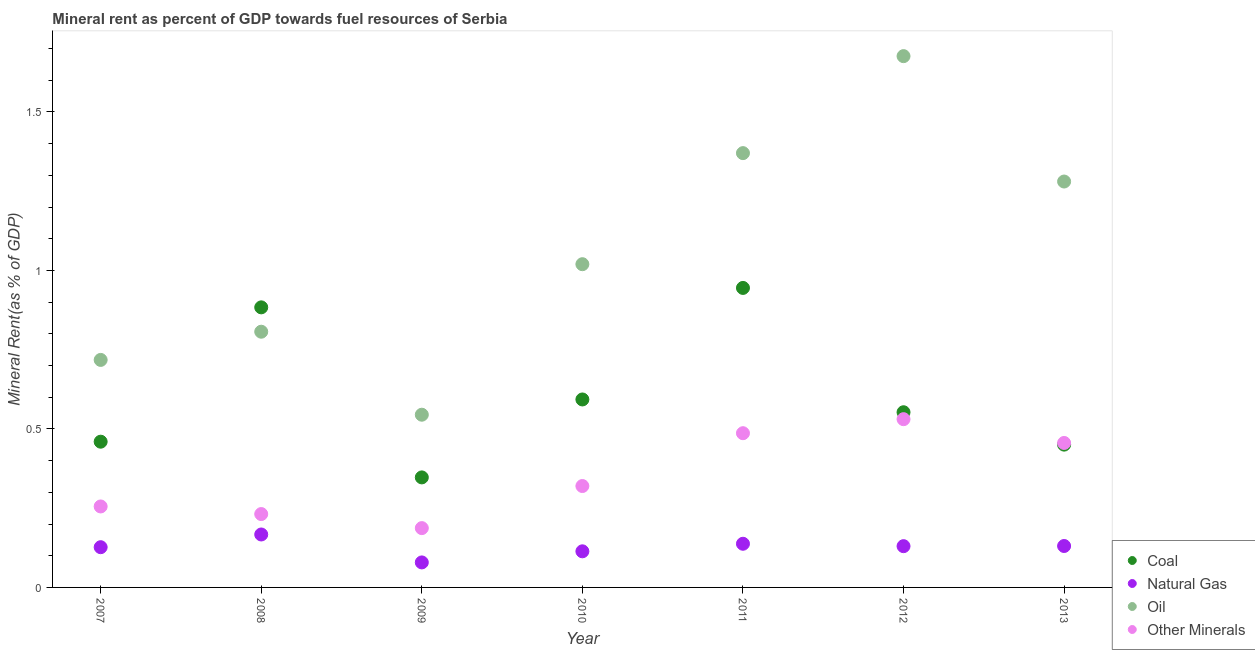What is the oil rent in 2007?
Keep it short and to the point. 0.72. Across all years, what is the maximum oil rent?
Offer a very short reply. 1.68. Across all years, what is the minimum natural gas rent?
Your answer should be very brief. 0.08. In which year was the oil rent minimum?
Your answer should be very brief. 2009. What is the total  rent of other minerals in the graph?
Your response must be concise. 2.47. What is the difference between the natural gas rent in 2007 and that in 2009?
Ensure brevity in your answer.  0.05. What is the difference between the coal rent in 2011 and the oil rent in 2012?
Provide a succinct answer. -0.73. What is the average oil rent per year?
Ensure brevity in your answer.  1.06. In the year 2012, what is the difference between the coal rent and oil rent?
Give a very brief answer. -1.12. In how many years, is the oil rent greater than 1.6 %?
Your answer should be very brief. 1. What is the ratio of the  rent of other minerals in 2009 to that in 2013?
Offer a very short reply. 0.41. What is the difference between the highest and the second highest natural gas rent?
Ensure brevity in your answer.  0.03. What is the difference between the highest and the lowest natural gas rent?
Your answer should be very brief. 0.09. In how many years, is the coal rent greater than the average coal rent taken over all years?
Keep it short and to the point. 2. Is the sum of the coal rent in 2010 and 2013 greater than the maximum  rent of other minerals across all years?
Keep it short and to the point. Yes. Is it the case that in every year, the sum of the coal rent and natural gas rent is greater than the sum of  rent of other minerals and oil rent?
Your answer should be compact. No. Is it the case that in every year, the sum of the coal rent and natural gas rent is greater than the oil rent?
Offer a very short reply. No. Does the  rent of other minerals monotonically increase over the years?
Provide a short and direct response. No. How many years are there in the graph?
Provide a short and direct response. 7. Are the values on the major ticks of Y-axis written in scientific E-notation?
Provide a short and direct response. No. Does the graph contain any zero values?
Your response must be concise. No. Does the graph contain grids?
Your answer should be compact. No. Where does the legend appear in the graph?
Provide a short and direct response. Bottom right. How many legend labels are there?
Your response must be concise. 4. What is the title of the graph?
Provide a succinct answer. Mineral rent as percent of GDP towards fuel resources of Serbia. What is the label or title of the X-axis?
Your answer should be very brief. Year. What is the label or title of the Y-axis?
Provide a short and direct response. Mineral Rent(as % of GDP). What is the Mineral Rent(as % of GDP) of Coal in 2007?
Ensure brevity in your answer.  0.46. What is the Mineral Rent(as % of GDP) of Natural Gas in 2007?
Your response must be concise. 0.13. What is the Mineral Rent(as % of GDP) in Oil in 2007?
Provide a succinct answer. 0.72. What is the Mineral Rent(as % of GDP) in Other Minerals in 2007?
Offer a terse response. 0.26. What is the Mineral Rent(as % of GDP) of Coal in 2008?
Your answer should be very brief. 0.88. What is the Mineral Rent(as % of GDP) in Natural Gas in 2008?
Ensure brevity in your answer.  0.17. What is the Mineral Rent(as % of GDP) of Oil in 2008?
Your answer should be very brief. 0.81. What is the Mineral Rent(as % of GDP) of Other Minerals in 2008?
Your answer should be compact. 0.23. What is the Mineral Rent(as % of GDP) in Coal in 2009?
Your answer should be compact. 0.35. What is the Mineral Rent(as % of GDP) of Natural Gas in 2009?
Provide a short and direct response. 0.08. What is the Mineral Rent(as % of GDP) in Oil in 2009?
Offer a terse response. 0.54. What is the Mineral Rent(as % of GDP) of Other Minerals in 2009?
Your response must be concise. 0.19. What is the Mineral Rent(as % of GDP) of Coal in 2010?
Give a very brief answer. 0.59. What is the Mineral Rent(as % of GDP) of Natural Gas in 2010?
Provide a succinct answer. 0.11. What is the Mineral Rent(as % of GDP) of Oil in 2010?
Make the answer very short. 1.02. What is the Mineral Rent(as % of GDP) of Other Minerals in 2010?
Make the answer very short. 0.32. What is the Mineral Rent(as % of GDP) in Coal in 2011?
Offer a very short reply. 0.94. What is the Mineral Rent(as % of GDP) in Natural Gas in 2011?
Your answer should be very brief. 0.14. What is the Mineral Rent(as % of GDP) of Oil in 2011?
Your answer should be compact. 1.37. What is the Mineral Rent(as % of GDP) of Other Minerals in 2011?
Offer a very short reply. 0.49. What is the Mineral Rent(as % of GDP) of Coal in 2012?
Keep it short and to the point. 0.55. What is the Mineral Rent(as % of GDP) of Natural Gas in 2012?
Offer a terse response. 0.13. What is the Mineral Rent(as % of GDP) of Oil in 2012?
Offer a very short reply. 1.68. What is the Mineral Rent(as % of GDP) in Other Minerals in 2012?
Your answer should be compact. 0.53. What is the Mineral Rent(as % of GDP) of Coal in 2013?
Offer a very short reply. 0.45. What is the Mineral Rent(as % of GDP) in Natural Gas in 2013?
Ensure brevity in your answer.  0.13. What is the Mineral Rent(as % of GDP) in Oil in 2013?
Ensure brevity in your answer.  1.28. What is the Mineral Rent(as % of GDP) in Other Minerals in 2013?
Offer a terse response. 0.46. Across all years, what is the maximum Mineral Rent(as % of GDP) in Coal?
Your answer should be very brief. 0.94. Across all years, what is the maximum Mineral Rent(as % of GDP) in Natural Gas?
Make the answer very short. 0.17. Across all years, what is the maximum Mineral Rent(as % of GDP) of Oil?
Your response must be concise. 1.68. Across all years, what is the maximum Mineral Rent(as % of GDP) of Other Minerals?
Ensure brevity in your answer.  0.53. Across all years, what is the minimum Mineral Rent(as % of GDP) of Coal?
Ensure brevity in your answer.  0.35. Across all years, what is the minimum Mineral Rent(as % of GDP) in Natural Gas?
Give a very brief answer. 0.08. Across all years, what is the minimum Mineral Rent(as % of GDP) in Oil?
Your answer should be very brief. 0.54. Across all years, what is the minimum Mineral Rent(as % of GDP) of Other Minerals?
Provide a succinct answer. 0.19. What is the total Mineral Rent(as % of GDP) in Coal in the graph?
Ensure brevity in your answer.  4.23. What is the total Mineral Rent(as % of GDP) of Natural Gas in the graph?
Offer a very short reply. 0.89. What is the total Mineral Rent(as % of GDP) of Oil in the graph?
Offer a very short reply. 7.42. What is the total Mineral Rent(as % of GDP) of Other Minerals in the graph?
Provide a short and direct response. 2.47. What is the difference between the Mineral Rent(as % of GDP) of Coal in 2007 and that in 2008?
Your answer should be very brief. -0.42. What is the difference between the Mineral Rent(as % of GDP) in Natural Gas in 2007 and that in 2008?
Your answer should be compact. -0.04. What is the difference between the Mineral Rent(as % of GDP) of Oil in 2007 and that in 2008?
Give a very brief answer. -0.09. What is the difference between the Mineral Rent(as % of GDP) in Other Minerals in 2007 and that in 2008?
Give a very brief answer. 0.02. What is the difference between the Mineral Rent(as % of GDP) of Coal in 2007 and that in 2009?
Give a very brief answer. 0.11. What is the difference between the Mineral Rent(as % of GDP) of Natural Gas in 2007 and that in 2009?
Offer a terse response. 0.05. What is the difference between the Mineral Rent(as % of GDP) in Oil in 2007 and that in 2009?
Your response must be concise. 0.17. What is the difference between the Mineral Rent(as % of GDP) of Other Minerals in 2007 and that in 2009?
Offer a terse response. 0.07. What is the difference between the Mineral Rent(as % of GDP) in Coal in 2007 and that in 2010?
Provide a short and direct response. -0.13. What is the difference between the Mineral Rent(as % of GDP) in Natural Gas in 2007 and that in 2010?
Provide a short and direct response. 0.01. What is the difference between the Mineral Rent(as % of GDP) of Oil in 2007 and that in 2010?
Your answer should be very brief. -0.3. What is the difference between the Mineral Rent(as % of GDP) of Other Minerals in 2007 and that in 2010?
Keep it short and to the point. -0.06. What is the difference between the Mineral Rent(as % of GDP) in Coal in 2007 and that in 2011?
Provide a succinct answer. -0.49. What is the difference between the Mineral Rent(as % of GDP) in Natural Gas in 2007 and that in 2011?
Provide a succinct answer. -0.01. What is the difference between the Mineral Rent(as % of GDP) of Oil in 2007 and that in 2011?
Make the answer very short. -0.65. What is the difference between the Mineral Rent(as % of GDP) of Other Minerals in 2007 and that in 2011?
Provide a short and direct response. -0.23. What is the difference between the Mineral Rent(as % of GDP) in Coal in 2007 and that in 2012?
Keep it short and to the point. -0.09. What is the difference between the Mineral Rent(as % of GDP) of Natural Gas in 2007 and that in 2012?
Provide a succinct answer. -0. What is the difference between the Mineral Rent(as % of GDP) of Oil in 2007 and that in 2012?
Offer a very short reply. -0.96. What is the difference between the Mineral Rent(as % of GDP) of Other Minerals in 2007 and that in 2012?
Give a very brief answer. -0.28. What is the difference between the Mineral Rent(as % of GDP) of Coal in 2007 and that in 2013?
Give a very brief answer. 0.01. What is the difference between the Mineral Rent(as % of GDP) in Natural Gas in 2007 and that in 2013?
Your answer should be very brief. -0. What is the difference between the Mineral Rent(as % of GDP) of Oil in 2007 and that in 2013?
Your response must be concise. -0.56. What is the difference between the Mineral Rent(as % of GDP) in Other Minerals in 2007 and that in 2013?
Your answer should be compact. -0.2. What is the difference between the Mineral Rent(as % of GDP) in Coal in 2008 and that in 2009?
Provide a succinct answer. 0.54. What is the difference between the Mineral Rent(as % of GDP) of Natural Gas in 2008 and that in 2009?
Make the answer very short. 0.09. What is the difference between the Mineral Rent(as % of GDP) in Oil in 2008 and that in 2009?
Give a very brief answer. 0.26. What is the difference between the Mineral Rent(as % of GDP) of Other Minerals in 2008 and that in 2009?
Provide a short and direct response. 0.04. What is the difference between the Mineral Rent(as % of GDP) of Coal in 2008 and that in 2010?
Offer a terse response. 0.29. What is the difference between the Mineral Rent(as % of GDP) of Natural Gas in 2008 and that in 2010?
Ensure brevity in your answer.  0.05. What is the difference between the Mineral Rent(as % of GDP) of Oil in 2008 and that in 2010?
Give a very brief answer. -0.21. What is the difference between the Mineral Rent(as % of GDP) in Other Minerals in 2008 and that in 2010?
Keep it short and to the point. -0.09. What is the difference between the Mineral Rent(as % of GDP) in Coal in 2008 and that in 2011?
Make the answer very short. -0.06. What is the difference between the Mineral Rent(as % of GDP) in Natural Gas in 2008 and that in 2011?
Offer a terse response. 0.03. What is the difference between the Mineral Rent(as % of GDP) of Oil in 2008 and that in 2011?
Offer a very short reply. -0.56. What is the difference between the Mineral Rent(as % of GDP) of Other Minerals in 2008 and that in 2011?
Your answer should be compact. -0.26. What is the difference between the Mineral Rent(as % of GDP) of Coal in 2008 and that in 2012?
Your answer should be very brief. 0.33. What is the difference between the Mineral Rent(as % of GDP) in Natural Gas in 2008 and that in 2012?
Your response must be concise. 0.04. What is the difference between the Mineral Rent(as % of GDP) of Oil in 2008 and that in 2012?
Your answer should be very brief. -0.87. What is the difference between the Mineral Rent(as % of GDP) in Other Minerals in 2008 and that in 2012?
Offer a very short reply. -0.3. What is the difference between the Mineral Rent(as % of GDP) of Coal in 2008 and that in 2013?
Your response must be concise. 0.43. What is the difference between the Mineral Rent(as % of GDP) in Natural Gas in 2008 and that in 2013?
Your answer should be compact. 0.04. What is the difference between the Mineral Rent(as % of GDP) in Oil in 2008 and that in 2013?
Provide a succinct answer. -0.47. What is the difference between the Mineral Rent(as % of GDP) of Other Minerals in 2008 and that in 2013?
Make the answer very short. -0.22. What is the difference between the Mineral Rent(as % of GDP) in Coal in 2009 and that in 2010?
Your answer should be compact. -0.25. What is the difference between the Mineral Rent(as % of GDP) of Natural Gas in 2009 and that in 2010?
Keep it short and to the point. -0.04. What is the difference between the Mineral Rent(as % of GDP) in Oil in 2009 and that in 2010?
Give a very brief answer. -0.47. What is the difference between the Mineral Rent(as % of GDP) in Other Minerals in 2009 and that in 2010?
Offer a very short reply. -0.13. What is the difference between the Mineral Rent(as % of GDP) in Coal in 2009 and that in 2011?
Offer a very short reply. -0.6. What is the difference between the Mineral Rent(as % of GDP) of Natural Gas in 2009 and that in 2011?
Give a very brief answer. -0.06. What is the difference between the Mineral Rent(as % of GDP) in Oil in 2009 and that in 2011?
Give a very brief answer. -0.83. What is the difference between the Mineral Rent(as % of GDP) of Other Minerals in 2009 and that in 2011?
Your response must be concise. -0.3. What is the difference between the Mineral Rent(as % of GDP) in Coal in 2009 and that in 2012?
Provide a short and direct response. -0.21. What is the difference between the Mineral Rent(as % of GDP) in Natural Gas in 2009 and that in 2012?
Make the answer very short. -0.05. What is the difference between the Mineral Rent(as % of GDP) of Oil in 2009 and that in 2012?
Offer a terse response. -1.13. What is the difference between the Mineral Rent(as % of GDP) of Other Minerals in 2009 and that in 2012?
Your answer should be compact. -0.34. What is the difference between the Mineral Rent(as % of GDP) of Coal in 2009 and that in 2013?
Provide a succinct answer. -0.1. What is the difference between the Mineral Rent(as % of GDP) in Natural Gas in 2009 and that in 2013?
Provide a short and direct response. -0.05. What is the difference between the Mineral Rent(as % of GDP) in Oil in 2009 and that in 2013?
Keep it short and to the point. -0.74. What is the difference between the Mineral Rent(as % of GDP) of Other Minerals in 2009 and that in 2013?
Make the answer very short. -0.27. What is the difference between the Mineral Rent(as % of GDP) in Coal in 2010 and that in 2011?
Give a very brief answer. -0.35. What is the difference between the Mineral Rent(as % of GDP) of Natural Gas in 2010 and that in 2011?
Ensure brevity in your answer.  -0.02. What is the difference between the Mineral Rent(as % of GDP) in Oil in 2010 and that in 2011?
Give a very brief answer. -0.35. What is the difference between the Mineral Rent(as % of GDP) in Coal in 2010 and that in 2012?
Offer a very short reply. 0.04. What is the difference between the Mineral Rent(as % of GDP) in Natural Gas in 2010 and that in 2012?
Keep it short and to the point. -0.02. What is the difference between the Mineral Rent(as % of GDP) in Oil in 2010 and that in 2012?
Keep it short and to the point. -0.66. What is the difference between the Mineral Rent(as % of GDP) in Other Minerals in 2010 and that in 2012?
Ensure brevity in your answer.  -0.21. What is the difference between the Mineral Rent(as % of GDP) of Coal in 2010 and that in 2013?
Provide a succinct answer. 0.14. What is the difference between the Mineral Rent(as % of GDP) of Natural Gas in 2010 and that in 2013?
Provide a succinct answer. -0.02. What is the difference between the Mineral Rent(as % of GDP) of Oil in 2010 and that in 2013?
Your answer should be compact. -0.26. What is the difference between the Mineral Rent(as % of GDP) of Other Minerals in 2010 and that in 2013?
Keep it short and to the point. -0.14. What is the difference between the Mineral Rent(as % of GDP) of Coal in 2011 and that in 2012?
Make the answer very short. 0.39. What is the difference between the Mineral Rent(as % of GDP) in Natural Gas in 2011 and that in 2012?
Offer a very short reply. 0.01. What is the difference between the Mineral Rent(as % of GDP) of Oil in 2011 and that in 2012?
Offer a terse response. -0.31. What is the difference between the Mineral Rent(as % of GDP) in Other Minerals in 2011 and that in 2012?
Make the answer very short. -0.04. What is the difference between the Mineral Rent(as % of GDP) in Coal in 2011 and that in 2013?
Give a very brief answer. 0.49. What is the difference between the Mineral Rent(as % of GDP) of Natural Gas in 2011 and that in 2013?
Make the answer very short. 0.01. What is the difference between the Mineral Rent(as % of GDP) of Oil in 2011 and that in 2013?
Provide a short and direct response. 0.09. What is the difference between the Mineral Rent(as % of GDP) in Other Minerals in 2011 and that in 2013?
Offer a terse response. 0.03. What is the difference between the Mineral Rent(as % of GDP) in Coal in 2012 and that in 2013?
Your answer should be very brief. 0.1. What is the difference between the Mineral Rent(as % of GDP) of Natural Gas in 2012 and that in 2013?
Offer a terse response. -0. What is the difference between the Mineral Rent(as % of GDP) in Oil in 2012 and that in 2013?
Your answer should be compact. 0.4. What is the difference between the Mineral Rent(as % of GDP) of Other Minerals in 2012 and that in 2013?
Offer a very short reply. 0.07. What is the difference between the Mineral Rent(as % of GDP) in Coal in 2007 and the Mineral Rent(as % of GDP) in Natural Gas in 2008?
Your answer should be very brief. 0.29. What is the difference between the Mineral Rent(as % of GDP) in Coal in 2007 and the Mineral Rent(as % of GDP) in Oil in 2008?
Provide a short and direct response. -0.35. What is the difference between the Mineral Rent(as % of GDP) in Coal in 2007 and the Mineral Rent(as % of GDP) in Other Minerals in 2008?
Your response must be concise. 0.23. What is the difference between the Mineral Rent(as % of GDP) of Natural Gas in 2007 and the Mineral Rent(as % of GDP) of Oil in 2008?
Give a very brief answer. -0.68. What is the difference between the Mineral Rent(as % of GDP) of Natural Gas in 2007 and the Mineral Rent(as % of GDP) of Other Minerals in 2008?
Your answer should be compact. -0.1. What is the difference between the Mineral Rent(as % of GDP) of Oil in 2007 and the Mineral Rent(as % of GDP) of Other Minerals in 2008?
Offer a terse response. 0.49. What is the difference between the Mineral Rent(as % of GDP) in Coal in 2007 and the Mineral Rent(as % of GDP) in Natural Gas in 2009?
Offer a terse response. 0.38. What is the difference between the Mineral Rent(as % of GDP) of Coal in 2007 and the Mineral Rent(as % of GDP) of Oil in 2009?
Offer a terse response. -0.09. What is the difference between the Mineral Rent(as % of GDP) of Coal in 2007 and the Mineral Rent(as % of GDP) of Other Minerals in 2009?
Your response must be concise. 0.27. What is the difference between the Mineral Rent(as % of GDP) of Natural Gas in 2007 and the Mineral Rent(as % of GDP) of Oil in 2009?
Give a very brief answer. -0.42. What is the difference between the Mineral Rent(as % of GDP) in Natural Gas in 2007 and the Mineral Rent(as % of GDP) in Other Minerals in 2009?
Ensure brevity in your answer.  -0.06. What is the difference between the Mineral Rent(as % of GDP) of Oil in 2007 and the Mineral Rent(as % of GDP) of Other Minerals in 2009?
Your answer should be very brief. 0.53. What is the difference between the Mineral Rent(as % of GDP) in Coal in 2007 and the Mineral Rent(as % of GDP) in Natural Gas in 2010?
Offer a very short reply. 0.35. What is the difference between the Mineral Rent(as % of GDP) of Coal in 2007 and the Mineral Rent(as % of GDP) of Oil in 2010?
Provide a succinct answer. -0.56. What is the difference between the Mineral Rent(as % of GDP) in Coal in 2007 and the Mineral Rent(as % of GDP) in Other Minerals in 2010?
Offer a terse response. 0.14. What is the difference between the Mineral Rent(as % of GDP) in Natural Gas in 2007 and the Mineral Rent(as % of GDP) in Oil in 2010?
Offer a terse response. -0.89. What is the difference between the Mineral Rent(as % of GDP) in Natural Gas in 2007 and the Mineral Rent(as % of GDP) in Other Minerals in 2010?
Offer a very short reply. -0.19. What is the difference between the Mineral Rent(as % of GDP) in Oil in 2007 and the Mineral Rent(as % of GDP) in Other Minerals in 2010?
Give a very brief answer. 0.4. What is the difference between the Mineral Rent(as % of GDP) of Coal in 2007 and the Mineral Rent(as % of GDP) of Natural Gas in 2011?
Give a very brief answer. 0.32. What is the difference between the Mineral Rent(as % of GDP) in Coal in 2007 and the Mineral Rent(as % of GDP) in Oil in 2011?
Give a very brief answer. -0.91. What is the difference between the Mineral Rent(as % of GDP) in Coal in 2007 and the Mineral Rent(as % of GDP) in Other Minerals in 2011?
Keep it short and to the point. -0.03. What is the difference between the Mineral Rent(as % of GDP) of Natural Gas in 2007 and the Mineral Rent(as % of GDP) of Oil in 2011?
Give a very brief answer. -1.24. What is the difference between the Mineral Rent(as % of GDP) of Natural Gas in 2007 and the Mineral Rent(as % of GDP) of Other Minerals in 2011?
Keep it short and to the point. -0.36. What is the difference between the Mineral Rent(as % of GDP) of Oil in 2007 and the Mineral Rent(as % of GDP) of Other Minerals in 2011?
Give a very brief answer. 0.23. What is the difference between the Mineral Rent(as % of GDP) of Coal in 2007 and the Mineral Rent(as % of GDP) of Natural Gas in 2012?
Offer a terse response. 0.33. What is the difference between the Mineral Rent(as % of GDP) of Coal in 2007 and the Mineral Rent(as % of GDP) of Oil in 2012?
Offer a terse response. -1.22. What is the difference between the Mineral Rent(as % of GDP) of Coal in 2007 and the Mineral Rent(as % of GDP) of Other Minerals in 2012?
Make the answer very short. -0.07. What is the difference between the Mineral Rent(as % of GDP) in Natural Gas in 2007 and the Mineral Rent(as % of GDP) in Oil in 2012?
Your answer should be very brief. -1.55. What is the difference between the Mineral Rent(as % of GDP) in Natural Gas in 2007 and the Mineral Rent(as % of GDP) in Other Minerals in 2012?
Your response must be concise. -0.4. What is the difference between the Mineral Rent(as % of GDP) in Oil in 2007 and the Mineral Rent(as % of GDP) in Other Minerals in 2012?
Ensure brevity in your answer.  0.19. What is the difference between the Mineral Rent(as % of GDP) in Coal in 2007 and the Mineral Rent(as % of GDP) in Natural Gas in 2013?
Your response must be concise. 0.33. What is the difference between the Mineral Rent(as % of GDP) in Coal in 2007 and the Mineral Rent(as % of GDP) in Oil in 2013?
Provide a short and direct response. -0.82. What is the difference between the Mineral Rent(as % of GDP) of Coal in 2007 and the Mineral Rent(as % of GDP) of Other Minerals in 2013?
Your answer should be compact. 0. What is the difference between the Mineral Rent(as % of GDP) of Natural Gas in 2007 and the Mineral Rent(as % of GDP) of Oil in 2013?
Your answer should be very brief. -1.15. What is the difference between the Mineral Rent(as % of GDP) of Natural Gas in 2007 and the Mineral Rent(as % of GDP) of Other Minerals in 2013?
Your response must be concise. -0.33. What is the difference between the Mineral Rent(as % of GDP) in Oil in 2007 and the Mineral Rent(as % of GDP) in Other Minerals in 2013?
Ensure brevity in your answer.  0.26. What is the difference between the Mineral Rent(as % of GDP) of Coal in 2008 and the Mineral Rent(as % of GDP) of Natural Gas in 2009?
Provide a succinct answer. 0.8. What is the difference between the Mineral Rent(as % of GDP) of Coal in 2008 and the Mineral Rent(as % of GDP) of Oil in 2009?
Give a very brief answer. 0.34. What is the difference between the Mineral Rent(as % of GDP) of Coal in 2008 and the Mineral Rent(as % of GDP) of Other Minerals in 2009?
Your response must be concise. 0.7. What is the difference between the Mineral Rent(as % of GDP) of Natural Gas in 2008 and the Mineral Rent(as % of GDP) of Oil in 2009?
Give a very brief answer. -0.38. What is the difference between the Mineral Rent(as % of GDP) of Natural Gas in 2008 and the Mineral Rent(as % of GDP) of Other Minerals in 2009?
Make the answer very short. -0.02. What is the difference between the Mineral Rent(as % of GDP) in Oil in 2008 and the Mineral Rent(as % of GDP) in Other Minerals in 2009?
Offer a terse response. 0.62. What is the difference between the Mineral Rent(as % of GDP) of Coal in 2008 and the Mineral Rent(as % of GDP) of Natural Gas in 2010?
Your answer should be very brief. 0.77. What is the difference between the Mineral Rent(as % of GDP) in Coal in 2008 and the Mineral Rent(as % of GDP) in Oil in 2010?
Provide a succinct answer. -0.14. What is the difference between the Mineral Rent(as % of GDP) of Coal in 2008 and the Mineral Rent(as % of GDP) of Other Minerals in 2010?
Ensure brevity in your answer.  0.56. What is the difference between the Mineral Rent(as % of GDP) of Natural Gas in 2008 and the Mineral Rent(as % of GDP) of Oil in 2010?
Provide a succinct answer. -0.85. What is the difference between the Mineral Rent(as % of GDP) in Natural Gas in 2008 and the Mineral Rent(as % of GDP) in Other Minerals in 2010?
Ensure brevity in your answer.  -0.15. What is the difference between the Mineral Rent(as % of GDP) in Oil in 2008 and the Mineral Rent(as % of GDP) in Other Minerals in 2010?
Keep it short and to the point. 0.49. What is the difference between the Mineral Rent(as % of GDP) in Coal in 2008 and the Mineral Rent(as % of GDP) in Natural Gas in 2011?
Provide a succinct answer. 0.75. What is the difference between the Mineral Rent(as % of GDP) in Coal in 2008 and the Mineral Rent(as % of GDP) in Oil in 2011?
Provide a short and direct response. -0.49. What is the difference between the Mineral Rent(as % of GDP) in Coal in 2008 and the Mineral Rent(as % of GDP) in Other Minerals in 2011?
Give a very brief answer. 0.4. What is the difference between the Mineral Rent(as % of GDP) of Natural Gas in 2008 and the Mineral Rent(as % of GDP) of Oil in 2011?
Offer a terse response. -1.2. What is the difference between the Mineral Rent(as % of GDP) in Natural Gas in 2008 and the Mineral Rent(as % of GDP) in Other Minerals in 2011?
Make the answer very short. -0.32. What is the difference between the Mineral Rent(as % of GDP) of Oil in 2008 and the Mineral Rent(as % of GDP) of Other Minerals in 2011?
Keep it short and to the point. 0.32. What is the difference between the Mineral Rent(as % of GDP) of Coal in 2008 and the Mineral Rent(as % of GDP) of Natural Gas in 2012?
Your answer should be very brief. 0.75. What is the difference between the Mineral Rent(as % of GDP) in Coal in 2008 and the Mineral Rent(as % of GDP) in Oil in 2012?
Keep it short and to the point. -0.79. What is the difference between the Mineral Rent(as % of GDP) of Coal in 2008 and the Mineral Rent(as % of GDP) of Other Minerals in 2012?
Provide a short and direct response. 0.35. What is the difference between the Mineral Rent(as % of GDP) in Natural Gas in 2008 and the Mineral Rent(as % of GDP) in Oil in 2012?
Offer a very short reply. -1.51. What is the difference between the Mineral Rent(as % of GDP) in Natural Gas in 2008 and the Mineral Rent(as % of GDP) in Other Minerals in 2012?
Your answer should be very brief. -0.36. What is the difference between the Mineral Rent(as % of GDP) in Oil in 2008 and the Mineral Rent(as % of GDP) in Other Minerals in 2012?
Give a very brief answer. 0.28. What is the difference between the Mineral Rent(as % of GDP) in Coal in 2008 and the Mineral Rent(as % of GDP) in Natural Gas in 2013?
Provide a succinct answer. 0.75. What is the difference between the Mineral Rent(as % of GDP) of Coal in 2008 and the Mineral Rent(as % of GDP) of Oil in 2013?
Make the answer very short. -0.4. What is the difference between the Mineral Rent(as % of GDP) in Coal in 2008 and the Mineral Rent(as % of GDP) in Other Minerals in 2013?
Ensure brevity in your answer.  0.43. What is the difference between the Mineral Rent(as % of GDP) of Natural Gas in 2008 and the Mineral Rent(as % of GDP) of Oil in 2013?
Provide a short and direct response. -1.11. What is the difference between the Mineral Rent(as % of GDP) in Natural Gas in 2008 and the Mineral Rent(as % of GDP) in Other Minerals in 2013?
Give a very brief answer. -0.29. What is the difference between the Mineral Rent(as % of GDP) in Oil in 2008 and the Mineral Rent(as % of GDP) in Other Minerals in 2013?
Your answer should be very brief. 0.35. What is the difference between the Mineral Rent(as % of GDP) of Coal in 2009 and the Mineral Rent(as % of GDP) of Natural Gas in 2010?
Ensure brevity in your answer.  0.23. What is the difference between the Mineral Rent(as % of GDP) of Coal in 2009 and the Mineral Rent(as % of GDP) of Oil in 2010?
Provide a short and direct response. -0.67. What is the difference between the Mineral Rent(as % of GDP) of Coal in 2009 and the Mineral Rent(as % of GDP) of Other Minerals in 2010?
Offer a terse response. 0.03. What is the difference between the Mineral Rent(as % of GDP) in Natural Gas in 2009 and the Mineral Rent(as % of GDP) in Oil in 2010?
Offer a very short reply. -0.94. What is the difference between the Mineral Rent(as % of GDP) of Natural Gas in 2009 and the Mineral Rent(as % of GDP) of Other Minerals in 2010?
Keep it short and to the point. -0.24. What is the difference between the Mineral Rent(as % of GDP) of Oil in 2009 and the Mineral Rent(as % of GDP) of Other Minerals in 2010?
Make the answer very short. 0.23. What is the difference between the Mineral Rent(as % of GDP) of Coal in 2009 and the Mineral Rent(as % of GDP) of Natural Gas in 2011?
Ensure brevity in your answer.  0.21. What is the difference between the Mineral Rent(as % of GDP) in Coal in 2009 and the Mineral Rent(as % of GDP) in Oil in 2011?
Offer a very short reply. -1.02. What is the difference between the Mineral Rent(as % of GDP) of Coal in 2009 and the Mineral Rent(as % of GDP) of Other Minerals in 2011?
Provide a short and direct response. -0.14. What is the difference between the Mineral Rent(as % of GDP) in Natural Gas in 2009 and the Mineral Rent(as % of GDP) in Oil in 2011?
Your answer should be very brief. -1.29. What is the difference between the Mineral Rent(as % of GDP) of Natural Gas in 2009 and the Mineral Rent(as % of GDP) of Other Minerals in 2011?
Offer a very short reply. -0.41. What is the difference between the Mineral Rent(as % of GDP) in Oil in 2009 and the Mineral Rent(as % of GDP) in Other Minerals in 2011?
Offer a very short reply. 0.06. What is the difference between the Mineral Rent(as % of GDP) in Coal in 2009 and the Mineral Rent(as % of GDP) in Natural Gas in 2012?
Give a very brief answer. 0.22. What is the difference between the Mineral Rent(as % of GDP) in Coal in 2009 and the Mineral Rent(as % of GDP) in Oil in 2012?
Offer a very short reply. -1.33. What is the difference between the Mineral Rent(as % of GDP) of Coal in 2009 and the Mineral Rent(as % of GDP) of Other Minerals in 2012?
Give a very brief answer. -0.18. What is the difference between the Mineral Rent(as % of GDP) of Natural Gas in 2009 and the Mineral Rent(as % of GDP) of Oil in 2012?
Keep it short and to the point. -1.6. What is the difference between the Mineral Rent(as % of GDP) in Natural Gas in 2009 and the Mineral Rent(as % of GDP) in Other Minerals in 2012?
Offer a terse response. -0.45. What is the difference between the Mineral Rent(as % of GDP) of Oil in 2009 and the Mineral Rent(as % of GDP) of Other Minerals in 2012?
Your response must be concise. 0.01. What is the difference between the Mineral Rent(as % of GDP) in Coal in 2009 and the Mineral Rent(as % of GDP) in Natural Gas in 2013?
Your response must be concise. 0.22. What is the difference between the Mineral Rent(as % of GDP) of Coal in 2009 and the Mineral Rent(as % of GDP) of Oil in 2013?
Your answer should be compact. -0.93. What is the difference between the Mineral Rent(as % of GDP) in Coal in 2009 and the Mineral Rent(as % of GDP) in Other Minerals in 2013?
Ensure brevity in your answer.  -0.11. What is the difference between the Mineral Rent(as % of GDP) in Natural Gas in 2009 and the Mineral Rent(as % of GDP) in Oil in 2013?
Offer a terse response. -1.2. What is the difference between the Mineral Rent(as % of GDP) in Natural Gas in 2009 and the Mineral Rent(as % of GDP) in Other Minerals in 2013?
Keep it short and to the point. -0.38. What is the difference between the Mineral Rent(as % of GDP) of Oil in 2009 and the Mineral Rent(as % of GDP) of Other Minerals in 2013?
Ensure brevity in your answer.  0.09. What is the difference between the Mineral Rent(as % of GDP) of Coal in 2010 and the Mineral Rent(as % of GDP) of Natural Gas in 2011?
Give a very brief answer. 0.46. What is the difference between the Mineral Rent(as % of GDP) of Coal in 2010 and the Mineral Rent(as % of GDP) of Oil in 2011?
Provide a short and direct response. -0.78. What is the difference between the Mineral Rent(as % of GDP) in Coal in 2010 and the Mineral Rent(as % of GDP) in Other Minerals in 2011?
Ensure brevity in your answer.  0.11. What is the difference between the Mineral Rent(as % of GDP) in Natural Gas in 2010 and the Mineral Rent(as % of GDP) in Oil in 2011?
Offer a terse response. -1.26. What is the difference between the Mineral Rent(as % of GDP) in Natural Gas in 2010 and the Mineral Rent(as % of GDP) in Other Minerals in 2011?
Your answer should be compact. -0.37. What is the difference between the Mineral Rent(as % of GDP) of Oil in 2010 and the Mineral Rent(as % of GDP) of Other Minerals in 2011?
Your answer should be compact. 0.53. What is the difference between the Mineral Rent(as % of GDP) of Coal in 2010 and the Mineral Rent(as % of GDP) of Natural Gas in 2012?
Offer a terse response. 0.46. What is the difference between the Mineral Rent(as % of GDP) in Coal in 2010 and the Mineral Rent(as % of GDP) in Oil in 2012?
Keep it short and to the point. -1.08. What is the difference between the Mineral Rent(as % of GDP) in Coal in 2010 and the Mineral Rent(as % of GDP) in Other Minerals in 2012?
Your answer should be compact. 0.06. What is the difference between the Mineral Rent(as % of GDP) of Natural Gas in 2010 and the Mineral Rent(as % of GDP) of Oil in 2012?
Offer a terse response. -1.56. What is the difference between the Mineral Rent(as % of GDP) in Natural Gas in 2010 and the Mineral Rent(as % of GDP) in Other Minerals in 2012?
Provide a short and direct response. -0.42. What is the difference between the Mineral Rent(as % of GDP) of Oil in 2010 and the Mineral Rent(as % of GDP) of Other Minerals in 2012?
Your response must be concise. 0.49. What is the difference between the Mineral Rent(as % of GDP) of Coal in 2010 and the Mineral Rent(as % of GDP) of Natural Gas in 2013?
Give a very brief answer. 0.46. What is the difference between the Mineral Rent(as % of GDP) in Coal in 2010 and the Mineral Rent(as % of GDP) in Oil in 2013?
Make the answer very short. -0.69. What is the difference between the Mineral Rent(as % of GDP) of Coal in 2010 and the Mineral Rent(as % of GDP) of Other Minerals in 2013?
Keep it short and to the point. 0.14. What is the difference between the Mineral Rent(as % of GDP) in Natural Gas in 2010 and the Mineral Rent(as % of GDP) in Oil in 2013?
Offer a very short reply. -1.17. What is the difference between the Mineral Rent(as % of GDP) of Natural Gas in 2010 and the Mineral Rent(as % of GDP) of Other Minerals in 2013?
Offer a very short reply. -0.34. What is the difference between the Mineral Rent(as % of GDP) of Oil in 2010 and the Mineral Rent(as % of GDP) of Other Minerals in 2013?
Offer a very short reply. 0.56. What is the difference between the Mineral Rent(as % of GDP) of Coal in 2011 and the Mineral Rent(as % of GDP) of Natural Gas in 2012?
Give a very brief answer. 0.81. What is the difference between the Mineral Rent(as % of GDP) in Coal in 2011 and the Mineral Rent(as % of GDP) in Oil in 2012?
Your answer should be compact. -0.73. What is the difference between the Mineral Rent(as % of GDP) of Coal in 2011 and the Mineral Rent(as % of GDP) of Other Minerals in 2012?
Make the answer very short. 0.41. What is the difference between the Mineral Rent(as % of GDP) in Natural Gas in 2011 and the Mineral Rent(as % of GDP) in Oil in 2012?
Your answer should be very brief. -1.54. What is the difference between the Mineral Rent(as % of GDP) of Natural Gas in 2011 and the Mineral Rent(as % of GDP) of Other Minerals in 2012?
Your answer should be compact. -0.39. What is the difference between the Mineral Rent(as % of GDP) of Oil in 2011 and the Mineral Rent(as % of GDP) of Other Minerals in 2012?
Provide a short and direct response. 0.84. What is the difference between the Mineral Rent(as % of GDP) in Coal in 2011 and the Mineral Rent(as % of GDP) in Natural Gas in 2013?
Provide a short and direct response. 0.81. What is the difference between the Mineral Rent(as % of GDP) of Coal in 2011 and the Mineral Rent(as % of GDP) of Oil in 2013?
Make the answer very short. -0.34. What is the difference between the Mineral Rent(as % of GDP) in Coal in 2011 and the Mineral Rent(as % of GDP) in Other Minerals in 2013?
Your response must be concise. 0.49. What is the difference between the Mineral Rent(as % of GDP) of Natural Gas in 2011 and the Mineral Rent(as % of GDP) of Oil in 2013?
Your answer should be compact. -1.14. What is the difference between the Mineral Rent(as % of GDP) of Natural Gas in 2011 and the Mineral Rent(as % of GDP) of Other Minerals in 2013?
Provide a succinct answer. -0.32. What is the difference between the Mineral Rent(as % of GDP) in Oil in 2011 and the Mineral Rent(as % of GDP) in Other Minerals in 2013?
Offer a terse response. 0.91. What is the difference between the Mineral Rent(as % of GDP) in Coal in 2012 and the Mineral Rent(as % of GDP) in Natural Gas in 2013?
Offer a terse response. 0.42. What is the difference between the Mineral Rent(as % of GDP) in Coal in 2012 and the Mineral Rent(as % of GDP) in Oil in 2013?
Keep it short and to the point. -0.73. What is the difference between the Mineral Rent(as % of GDP) of Coal in 2012 and the Mineral Rent(as % of GDP) of Other Minerals in 2013?
Your response must be concise. 0.1. What is the difference between the Mineral Rent(as % of GDP) in Natural Gas in 2012 and the Mineral Rent(as % of GDP) in Oil in 2013?
Give a very brief answer. -1.15. What is the difference between the Mineral Rent(as % of GDP) in Natural Gas in 2012 and the Mineral Rent(as % of GDP) in Other Minerals in 2013?
Your answer should be compact. -0.33. What is the difference between the Mineral Rent(as % of GDP) in Oil in 2012 and the Mineral Rent(as % of GDP) in Other Minerals in 2013?
Your answer should be compact. 1.22. What is the average Mineral Rent(as % of GDP) in Coal per year?
Make the answer very short. 0.6. What is the average Mineral Rent(as % of GDP) of Natural Gas per year?
Provide a succinct answer. 0.13. What is the average Mineral Rent(as % of GDP) in Oil per year?
Keep it short and to the point. 1.06. What is the average Mineral Rent(as % of GDP) in Other Minerals per year?
Make the answer very short. 0.35. In the year 2007, what is the difference between the Mineral Rent(as % of GDP) in Coal and Mineral Rent(as % of GDP) in Natural Gas?
Your response must be concise. 0.33. In the year 2007, what is the difference between the Mineral Rent(as % of GDP) in Coal and Mineral Rent(as % of GDP) in Oil?
Your answer should be very brief. -0.26. In the year 2007, what is the difference between the Mineral Rent(as % of GDP) in Coal and Mineral Rent(as % of GDP) in Other Minerals?
Keep it short and to the point. 0.2. In the year 2007, what is the difference between the Mineral Rent(as % of GDP) in Natural Gas and Mineral Rent(as % of GDP) in Oil?
Make the answer very short. -0.59. In the year 2007, what is the difference between the Mineral Rent(as % of GDP) in Natural Gas and Mineral Rent(as % of GDP) in Other Minerals?
Your answer should be compact. -0.13. In the year 2007, what is the difference between the Mineral Rent(as % of GDP) of Oil and Mineral Rent(as % of GDP) of Other Minerals?
Ensure brevity in your answer.  0.46. In the year 2008, what is the difference between the Mineral Rent(as % of GDP) of Coal and Mineral Rent(as % of GDP) of Natural Gas?
Offer a terse response. 0.72. In the year 2008, what is the difference between the Mineral Rent(as % of GDP) in Coal and Mineral Rent(as % of GDP) in Oil?
Give a very brief answer. 0.08. In the year 2008, what is the difference between the Mineral Rent(as % of GDP) of Coal and Mineral Rent(as % of GDP) of Other Minerals?
Provide a short and direct response. 0.65. In the year 2008, what is the difference between the Mineral Rent(as % of GDP) in Natural Gas and Mineral Rent(as % of GDP) in Oil?
Ensure brevity in your answer.  -0.64. In the year 2008, what is the difference between the Mineral Rent(as % of GDP) of Natural Gas and Mineral Rent(as % of GDP) of Other Minerals?
Your answer should be very brief. -0.06. In the year 2008, what is the difference between the Mineral Rent(as % of GDP) of Oil and Mineral Rent(as % of GDP) of Other Minerals?
Provide a succinct answer. 0.58. In the year 2009, what is the difference between the Mineral Rent(as % of GDP) in Coal and Mineral Rent(as % of GDP) in Natural Gas?
Provide a short and direct response. 0.27. In the year 2009, what is the difference between the Mineral Rent(as % of GDP) of Coal and Mineral Rent(as % of GDP) of Oil?
Keep it short and to the point. -0.2. In the year 2009, what is the difference between the Mineral Rent(as % of GDP) in Coal and Mineral Rent(as % of GDP) in Other Minerals?
Keep it short and to the point. 0.16. In the year 2009, what is the difference between the Mineral Rent(as % of GDP) of Natural Gas and Mineral Rent(as % of GDP) of Oil?
Ensure brevity in your answer.  -0.47. In the year 2009, what is the difference between the Mineral Rent(as % of GDP) in Natural Gas and Mineral Rent(as % of GDP) in Other Minerals?
Your response must be concise. -0.11. In the year 2009, what is the difference between the Mineral Rent(as % of GDP) of Oil and Mineral Rent(as % of GDP) of Other Minerals?
Your answer should be very brief. 0.36. In the year 2010, what is the difference between the Mineral Rent(as % of GDP) of Coal and Mineral Rent(as % of GDP) of Natural Gas?
Keep it short and to the point. 0.48. In the year 2010, what is the difference between the Mineral Rent(as % of GDP) in Coal and Mineral Rent(as % of GDP) in Oil?
Provide a short and direct response. -0.43. In the year 2010, what is the difference between the Mineral Rent(as % of GDP) of Coal and Mineral Rent(as % of GDP) of Other Minerals?
Keep it short and to the point. 0.27. In the year 2010, what is the difference between the Mineral Rent(as % of GDP) of Natural Gas and Mineral Rent(as % of GDP) of Oil?
Make the answer very short. -0.91. In the year 2010, what is the difference between the Mineral Rent(as % of GDP) in Natural Gas and Mineral Rent(as % of GDP) in Other Minerals?
Ensure brevity in your answer.  -0.21. In the year 2010, what is the difference between the Mineral Rent(as % of GDP) in Oil and Mineral Rent(as % of GDP) in Other Minerals?
Give a very brief answer. 0.7. In the year 2011, what is the difference between the Mineral Rent(as % of GDP) in Coal and Mineral Rent(as % of GDP) in Natural Gas?
Your answer should be very brief. 0.81. In the year 2011, what is the difference between the Mineral Rent(as % of GDP) in Coal and Mineral Rent(as % of GDP) in Oil?
Give a very brief answer. -0.43. In the year 2011, what is the difference between the Mineral Rent(as % of GDP) of Coal and Mineral Rent(as % of GDP) of Other Minerals?
Provide a succinct answer. 0.46. In the year 2011, what is the difference between the Mineral Rent(as % of GDP) of Natural Gas and Mineral Rent(as % of GDP) of Oil?
Provide a short and direct response. -1.23. In the year 2011, what is the difference between the Mineral Rent(as % of GDP) of Natural Gas and Mineral Rent(as % of GDP) of Other Minerals?
Your answer should be very brief. -0.35. In the year 2011, what is the difference between the Mineral Rent(as % of GDP) in Oil and Mineral Rent(as % of GDP) in Other Minerals?
Give a very brief answer. 0.88. In the year 2012, what is the difference between the Mineral Rent(as % of GDP) of Coal and Mineral Rent(as % of GDP) of Natural Gas?
Your response must be concise. 0.42. In the year 2012, what is the difference between the Mineral Rent(as % of GDP) of Coal and Mineral Rent(as % of GDP) of Oil?
Your response must be concise. -1.12. In the year 2012, what is the difference between the Mineral Rent(as % of GDP) in Coal and Mineral Rent(as % of GDP) in Other Minerals?
Offer a very short reply. 0.02. In the year 2012, what is the difference between the Mineral Rent(as % of GDP) in Natural Gas and Mineral Rent(as % of GDP) in Oil?
Your answer should be compact. -1.55. In the year 2012, what is the difference between the Mineral Rent(as % of GDP) of Natural Gas and Mineral Rent(as % of GDP) of Other Minerals?
Offer a terse response. -0.4. In the year 2012, what is the difference between the Mineral Rent(as % of GDP) in Oil and Mineral Rent(as % of GDP) in Other Minerals?
Offer a terse response. 1.15. In the year 2013, what is the difference between the Mineral Rent(as % of GDP) in Coal and Mineral Rent(as % of GDP) in Natural Gas?
Provide a succinct answer. 0.32. In the year 2013, what is the difference between the Mineral Rent(as % of GDP) in Coal and Mineral Rent(as % of GDP) in Oil?
Offer a terse response. -0.83. In the year 2013, what is the difference between the Mineral Rent(as % of GDP) of Coal and Mineral Rent(as % of GDP) of Other Minerals?
Your answer should be very brief. -0.01. In the year 2013, what is the difference between the Mineral Rent(as % of GDP) of Natural Gas and Mineral Rent(as % of GDP) of Oil?
Your answer should be very brief. -1.15. In the year 2013, what is the difference between the Mineral Rent(as % of GDP) of Natural Gas and Mineral Rent(as % of GDP) of Other Minerals?
Keep it short and to the point. -0.33. In the year 2013, what is the difference between the Mineral Rent(as % of GDP) in Oil and Mineral Rent(as % of GDP) in Other Minerals?
Ensure brevity in your answer.  0.82. What is the ratio of the Mineral Rent(as % of GDP) in Coal in 2007 to that in 2008?
Make the answer very short. 0.52. What is the ratio of the Mineral Rent(as % of GDP) in Natural Gas in 2007 to that in 2008?
Ensure brevity in your answer.  0.76. What is the ratio of the Mineral Rent(as % of GDP) of Oil in 2007 to that in 2008?
Make the answer very short. 0.89. What is the ratio of the Mineral Rent(as % of GDP) in Other Minerals in 2007 to that in 2008?
Your answer should be very brief. 1.1. What is the ratio of the Mineral Rent(as % of GDP) of Coal in 2007 to that in 2009?
Keep it short and to the point. 1.32. What is the ratio of the Mineral Rent(as % of GDP) in Natural Gas in 2007 to that in 2009?
Offer a very short reply. 1.61. What is the ratio of the Mineral Rent(as % of GDP) in Oil in 2007 to that in 2009?
Ensure brevity in your answer.  1.32. What is the ratio of the Mineral Rent(as % of GDP) in Other Minerals in 2007 to that in 2009?
Offer a very short reply. 1.37. What is the ratio of the Mineral Rent(as % of GDP) in Coal in 2007 to that in 2010?
Ensure brevity in your answer.  0.78. What is the ratio of the Mineral Rent(as % of GDP) of Natural Gas in 2007 to that in 2010?
Ensure brevity in your answer.  1.11. What is the ratio of the Mineral Rent(as % of GDP) of Oil in 2007 to that in 2010?
Keep it short and to the point. 0.7. What is the ratio of the Mineral Rent(as % of GDP) in Other Minerals in 2007 to that in 2010?
Your answer should be very brief. 0.8. What is the ratio of the Mineral Rent(as % of GDP) of Coal in 2007 to that in 2011?
Provide a short and direct response. 0.49. What is the ratio of the Mineral Rent(as % of GDP) of Natural Gas in 2007 to that in 2011?
Your response must be concise. 0.92. What is the ratio of the Mineral Rent(as % of GDP) of Oil in 2007 to that in 2011?
Your response must be concise. 0.52. What is the ratio of the Mineral Rent(as % of GDP) of Other Minerals in 2007 to that in 2011?
Make the answer very short. 0.53. What is the ratio of the Mineral Rent(as % of GDP) of Coal in 2007 to that in 2012?
Offer a terse response. 0.83. What is the ratio of the Mineral Rent(as % of GDP) in Natural Gas in 2007 to that in 2012?
Offer a terse response. 0.97. What is the ratio of the Mineral Rent(as % of GDP) in Oil in 2007 to that in 2012?
Your answer should be compact. 0.43. What is the ratio of the Mineral Rent(as % of GDP) of Other Minerals in 2007 to that in 2012?
Your answer should be compact. 0.48. What is the ratio of the Mineral Rent(as % of GDP) in Coal in 2007 to that in 2013?
Give a very brief answer. 1.02. What is the ratio of the Mineral Rent(as % of GDP) in Natural Gas in 2007 to that in 2013?
Keep it short and to the point. 0.97. What is the ratio of the Mineral Rent(as % of GDP) in Oil in 2007 to that in 2013?
Provide a short and direct response. 0.56. What is the ratio of the Mineral Rent(as % of GDP) in Other Minerals in 2007 to that in 2013?
Ensure brevity in your answer.  0.56. What is the ratio of the Mineral Rent(as % of GDP) in Coal in 2008 to that in 2009?
Offer a terse response. 2.55. What is the ratio of the Mineral Rent(as % of GDP) of Natural Gas in 2008 to that in 2009?
Your answer should be very brief. 2.12. What is the ratio of the Mineral Rent(as % of GDP) in Oil in 2008 to that in 2009?
Your answer should be very brief. 1.48. What is the ratio of the Mineral Rent(as % of GDP) of Other Minerals in 2008 to that in 2009?
Your answer should be very brief. 1.24. What is the ratio of the Mineral Rent(as % of GDP) of Coal in 2008 to that in 2010?
Your response must be concise. 1.49. What is the ratio of the Mineral Rent(as % of GDP) of Natural Gas in 2008 to that in 2010?
Your response must be concise. 1.47. What is the ratio of the Mineral Rent(as % of GDP) of Oil in 2008 to that in 2010?
Offer a terse response. 0.79. What is the ratio of the Mineral Rent(as % of GDP) of Other Minerals in 2008 to that in 2010?
Provide a short and direct response. 0.72. What is the ratio of the Mineral Rent(as % of GDP) of Coal in 2008 to that in 2011?
Your response must be concise. 0.94. What is the ratio of the Mineral Rent(as % of GDP) in Natural Gas in 2008 to that in 2011?
Keep it short and to the point. 1.21. What is the ratio of the Mineral Rent(as % of GDP) in Oil in 2008 to that in 2011?
Ensure brevity in your answer.  0.59. What is the ratio of the Mineral Rent(as % of GDP) in Other Minerals in 2008 to that in 2011?
Make the answer very short. 0.48. What is the ratio of the Mineral Rent(as % of GDP) of Coal in 2008 to that in 2012?
Provide a succinct answer. 1.6. What is the ratio of the Mineral Rent(as % of GDP) in Natural Gas in 2008 to that in 2012?
Your answer should be very brief. 1.28. What is the ratio of the Mineral Rent(as % of GDP) of Oil in 2008 to that in 2012?
Offer a very short reply. 0.48. What is the ratio of the Mineral Rent(as % of GDP) of Other Minerals in 2008 to that in 2012?
Provide a succinct answer. 0.44. What is the ratio of the Mineral Rent(as % of GDP) of Coal in 2008 to that in 2013?
Give a very brief answer. 1.96. What is the ratio of the Mineral Rent(as % of GDP) in Natural Gas in 2008 to that in 2013?
Your response must be concise. 1.28. What is the ratio of the Mineral Rent(as % of GDP) of Oil in 2008 to that in 2013?
Offer a terse response. 0.63. What is the ratio of the Mineral Rent(as % of GDP) in Other Minerals in 2008 to that in 2013?
Provide a succinct answer. 0.51. What is the ratio of the Mineral Rent(as % of GDP) of Coal in 2009 to that in 2010?
Keep it short and to the point. 0.59. What is the ratio of the Mineral Rent(as % of GDP) in Natural Gas in 2009 to that in 2010?
Your answer should be very brief. 0.69. What is the ratio of the Mineral Rent(as % of GDP) of Oil in 2009 to that in 2010?
Your answer should be very brief. 0.53. What is the ratio of the Mineral Rent(as % of GDP) in Other Minerals in 2009 to that in 2010?
Give a very brief answer. 0.58. What is the ratio of the Mineral Rent(as % of GDP) of Coal in 2009 to that in 2011?
Keep it short and to the point. 0.37. What is the ratio of the Mineral Rent(as % of GDP) in Natural Gas in 2009 to that in 2011?
Provide a short and direct response. 0.57. What is the ratio of the Mineral Rent(as % of GDP) in Oil in 2009 to that in 2011?
Offer a very short reply. 0.4. What is the ratio of the Mineral Rent(as % of GDP) of Other Minerals in 2009 to that in 2011?
Offer a very short reply. 0.38. What is the ratio of the Mineral Rent(as % of GDP) of Coal in 2009 to that in 2012?
Provide a succinct answer. 0.63. What is the ratio of the Mineral Rent(as % of GDP) of Natural Gas in 2009 to that in 2012?
Give a very brief answer. 0.61. What is the ratio of the Mineral Rent(as % of GDP) in Oil in 2009 to that in 2012?
Provide a short and direct response. 0.33. What is the ratio of the Mineral Rent(as % of GDP) of Other Minerals in 2009 to that in 2012?
Give a very brief answer. 0.35. What is the ratio of the Mineral Rent(as % of GDP) in Coal in 2009 to that in 2013?
Your answer should be very brief. 0.77. What is the ratio of the Mineral Rent(as % of GDP) of Natural Gas in 2009 to that in 2013?
Your response must be concise. 0.6. What is the ratio of the Mineral Rent(as % of GDP) in Oil in 2009 to that in 2013?
Give a very brief answer. 0.43. What is the ratio of the Mineral Rent(as % of GDP) of Other Minerals in 2009 to that in 2013?
Give a very brief answer. 0.41. What is the ratio of the Mineral Rent(as % of GDP) of Coal in 2010 to that in 2011?
Your answer should be compact. 0.63. What is the ratio of the Mineral Rent(as % of GDP) of Natural Gas in 2010 to that in 2011?
Your answer should be very brief. 0.83. What is the ratio of the Mineral Rent(as % of GDP) of Oil in 2010 to that in 2011?
Offer a terse response. 0.74. What is the ratio of the Mineral Rent(as % of GDP) of Other Minerals in 2010 to that in 2011?
Your response must be concise. 0.66. What is the ratio of the Mineral Rent(as % of GDP) of Coal in 2010 to that in 2012?
Your response must be concise. 1.07. What is the ratio of the Mineral Rent(as % of GDP) in Natural Gas in 2010 to that in 2012?
Provide a succinct answer. 0.88. What is the ratio of the Mineral Rent(as % of GDP) in Oil in 2010 to that in 2012?
Offer a very short reply. 0.61. What is the ratio of the Mineral Rent(as % of GDP) of Other Minerals in 2010 to that in 2012?
Your answer should be compact. 0.6. What is the ratio of the Mineral Rent(as % of GDP) of Coal in 2010 to that in 2013?
Ensure brevity in your answer.  1.32. What is the ratio of the Mineral Rent(as % of GDP) of Natural Gas in 2010 to that in 2013?
Provide a short and direct response. 0.87. What is the ratio of the Mineral Rent(as % of GDP) of Oil in 2010 to that in 2013?
Provide a short and direct response. 0.8. What is the ratio of the Mineral Rent(as % of GDP) in Other Minerals in 2010 to that in 2013?
Your answer should be compact. 0.7. What is the ratio of the Mineral Rent(as % of GDP) in Coal in 2011 to that in 2012?
Provide a short and direct response. 1.71. What is the ratio of the Mineral Rent(as % of GDP) of Natural Gas in 2011 to that in 2012?
Your answer should be compact. 1.06. What is the ratio of the Mineral Rent(as % of GDP) of Oil in 2011 to that in 2012?
Your response must be concise. 0.82. What is the ratio of the Mineral Rent(as % of GDP) in Other Minerals in 2011 to that in 2012?
Offer a very short reply. 0.92. What is the ratio of the Mineral Rent(as % of GDP) in Coal in 2011 to that in 2013?
Your answer should be very brief. 2.1. What is the ratio of the Mineral Rent(as % of GDP) in Natural Gas in 2011 to that in 2013?
Your answer should be very brief. 1.05. What is the ratio of the Mineral Rent(as % of GDP) in Oil in 2011 to that in 2013?
Make the answer very short. 1.07. What is the ratio of the Mineral Rent(as % of GDP) of Other Minerals in 2011 to that in 2013?
Make the answer very short. 1.07. What is the ratio of the Mineral Rent(as % of GDP) of Coal in 2012 to that in 2013?
Provide a short and direct response. 1.23. What is the ratio of the Mineral Rent(as % of GDP) of Oil in 2012 to that in 2013?
Provide a short and direct response. 1.31. What is the ratio of the Mineral Rent(as % of GDP) of Other Minerals in 2012 to that in 2013?
Make the answer very short. 1.16. What is the difference between the highest and the second highest Mineral Rent(as % of GDP) in Coal?
Provide a short and direct response. 0.06. What is the difference between the highest and the second highest Mineral Rent(as % of GDP) in Natural Gas?
Make the answer very short. 0.03. What is the difference between the highest and the second highest Mineral Rent(as % of GDP) in Oil?
Make the answer very short. 0.31. What is the difference between the highest and the second highest Mineral Rent(as % of GDP) of Other Minerals?
Provide a succinct answer. 0.04. What is the difference between the highest and the lowest Mineral Rent(as % of GDP) in Coal?
Provide a succinct answer. 0.6. What is the difference between the highest and the lowest Mineral Rent(as % of GDP) in Natural Gas?
Ensure brevity in your answer.  0.09. What is the difference between the highest and the lowest Mineral Rent(as % of GDP) in Oil?
Your answer should be very brief. 1.13. What is the difference between the highest and the lowest Mineral Rent(as % of GDP) in Other Minerals?
Offer a terse response. 0.34. 